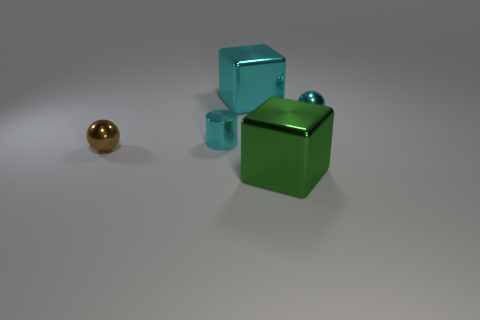Add 3 small brown metal balls. How many objects exist? 8 Subtract all blocks. How many objects are left? 3 Subtract 0 red cylinders. How many objects are left? 5 Subtract all small green blocks. Subtract all green things. How many objects are left? 4 Add 1 big shiny things. How many big shiny things are left? 3 Add 5 green shiny objects. How many green shiny objects exist? 6 